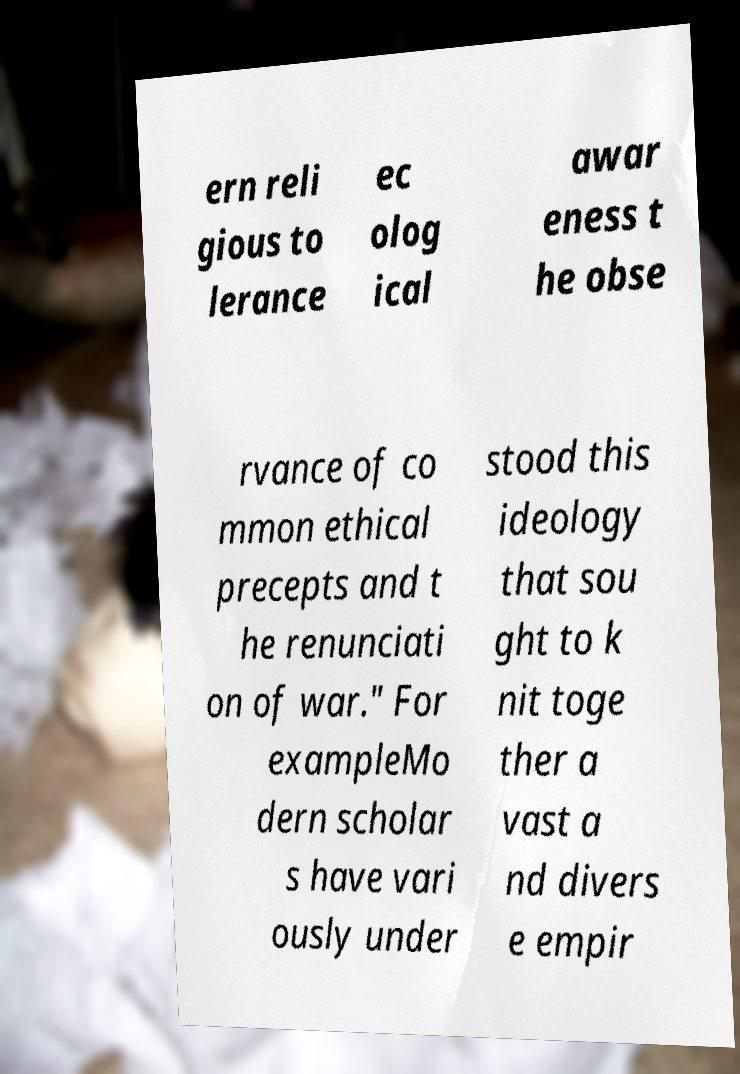Could you extract and type out the text from this image? ern reli gious to lerance ec olog ical awar eness t he obse rvance of co mmon ethical precepts and t he renunciati on of war." For exampleMo dern scholar s have vari ously under stood this ideology that sou ght to k nit toge ther a vast a nd divers e empir 